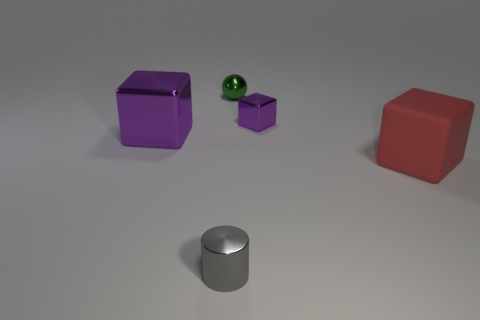What is the material of the large cube in front of the large thing that is left of the large rubber cube?
Provide a succinct answer. Rubber. There is a tiny object that is in front of the green metallic thing and on the right side of the gray shiny object; what is it made of?
Keep it short and to the point. Metal. Are there any small objects that have the same shape as the big red matte thing?
Your response must be concise. Yes. There is a purple shiny block on the left side of the green shiny object; are there any red matte blocks on the left side of it?
Your answer should be very brief. No. How many tiny blocks have the same material as the small cylinder?
Ensure brevity in your answer.  1. Are there any purple metallic balls?
Offer a terse response. No. What number of shiny objects are the same color as the big metallic block?
Your answer should be compact. 1. Is the material of the cylinder the same as the large block that is to the right of the green object?
Provide a succinct answer. No. Are there more green balls that are behind the red rubber block than large blue rubber things?
Offer a very short reply. Yes. Is there any other thing that has the same size as the red thing?
Make the answer very short. Yes. 